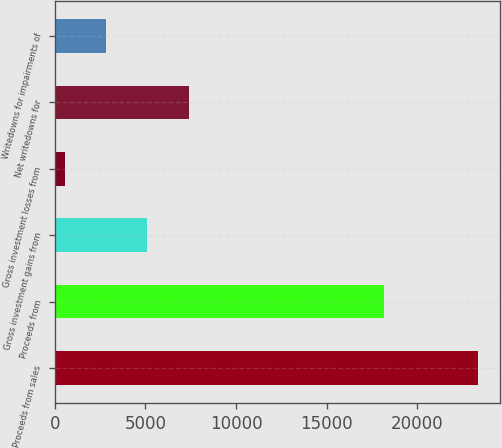Convert chart to OTSL. <chart><loc_0><loc_0><loc_500><loc_500><bar_chart><fcel>Proceeds from sales<fcel>Proceeds from<fcel>Gross investment gains from<fcel>Gross investment losses from<fcel>Net writedowns for<fcel>Writedowns for impairments of<nl><fcel>23390<fcel>18182<fcel>5106<fcel>535<fcel>7391.5<fcel>2820.5<nl></chart> 